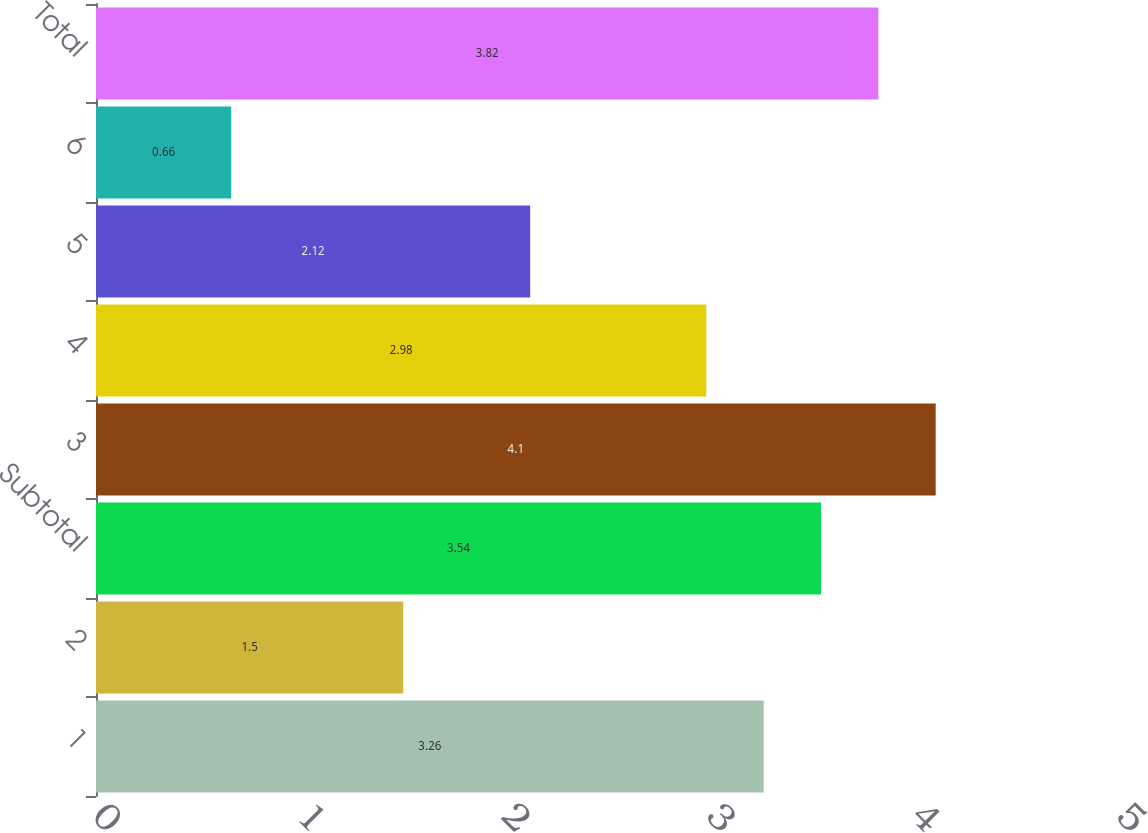<chart> <loc_0><loc_0><loc_500><loc_500><bar_chart><fcel>1<fcel>2<fcel>Subtotal<fcel>3<fcel>4<fcel>5<fcel>6<fcel>Total<nl><fcel>3.26<fcel>1.5<fcel>3.54<fcel>4.1<fcel>2.98<fcel>2.12<fcel>0.66<fcel>3.82<nl></chart> 